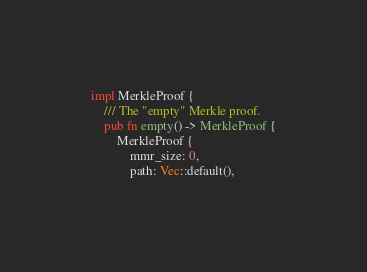Convert code to text. <code><loc_0><loc_0><loc_500><loc_500><_Rust_>impl MerkleProof {
	/// The "empty" Merkle proof.
	pub fn empty() -> MerkleProof {
		MerkleProof {
			mmr_size: 0,
			path: Vec::default(),</code> 